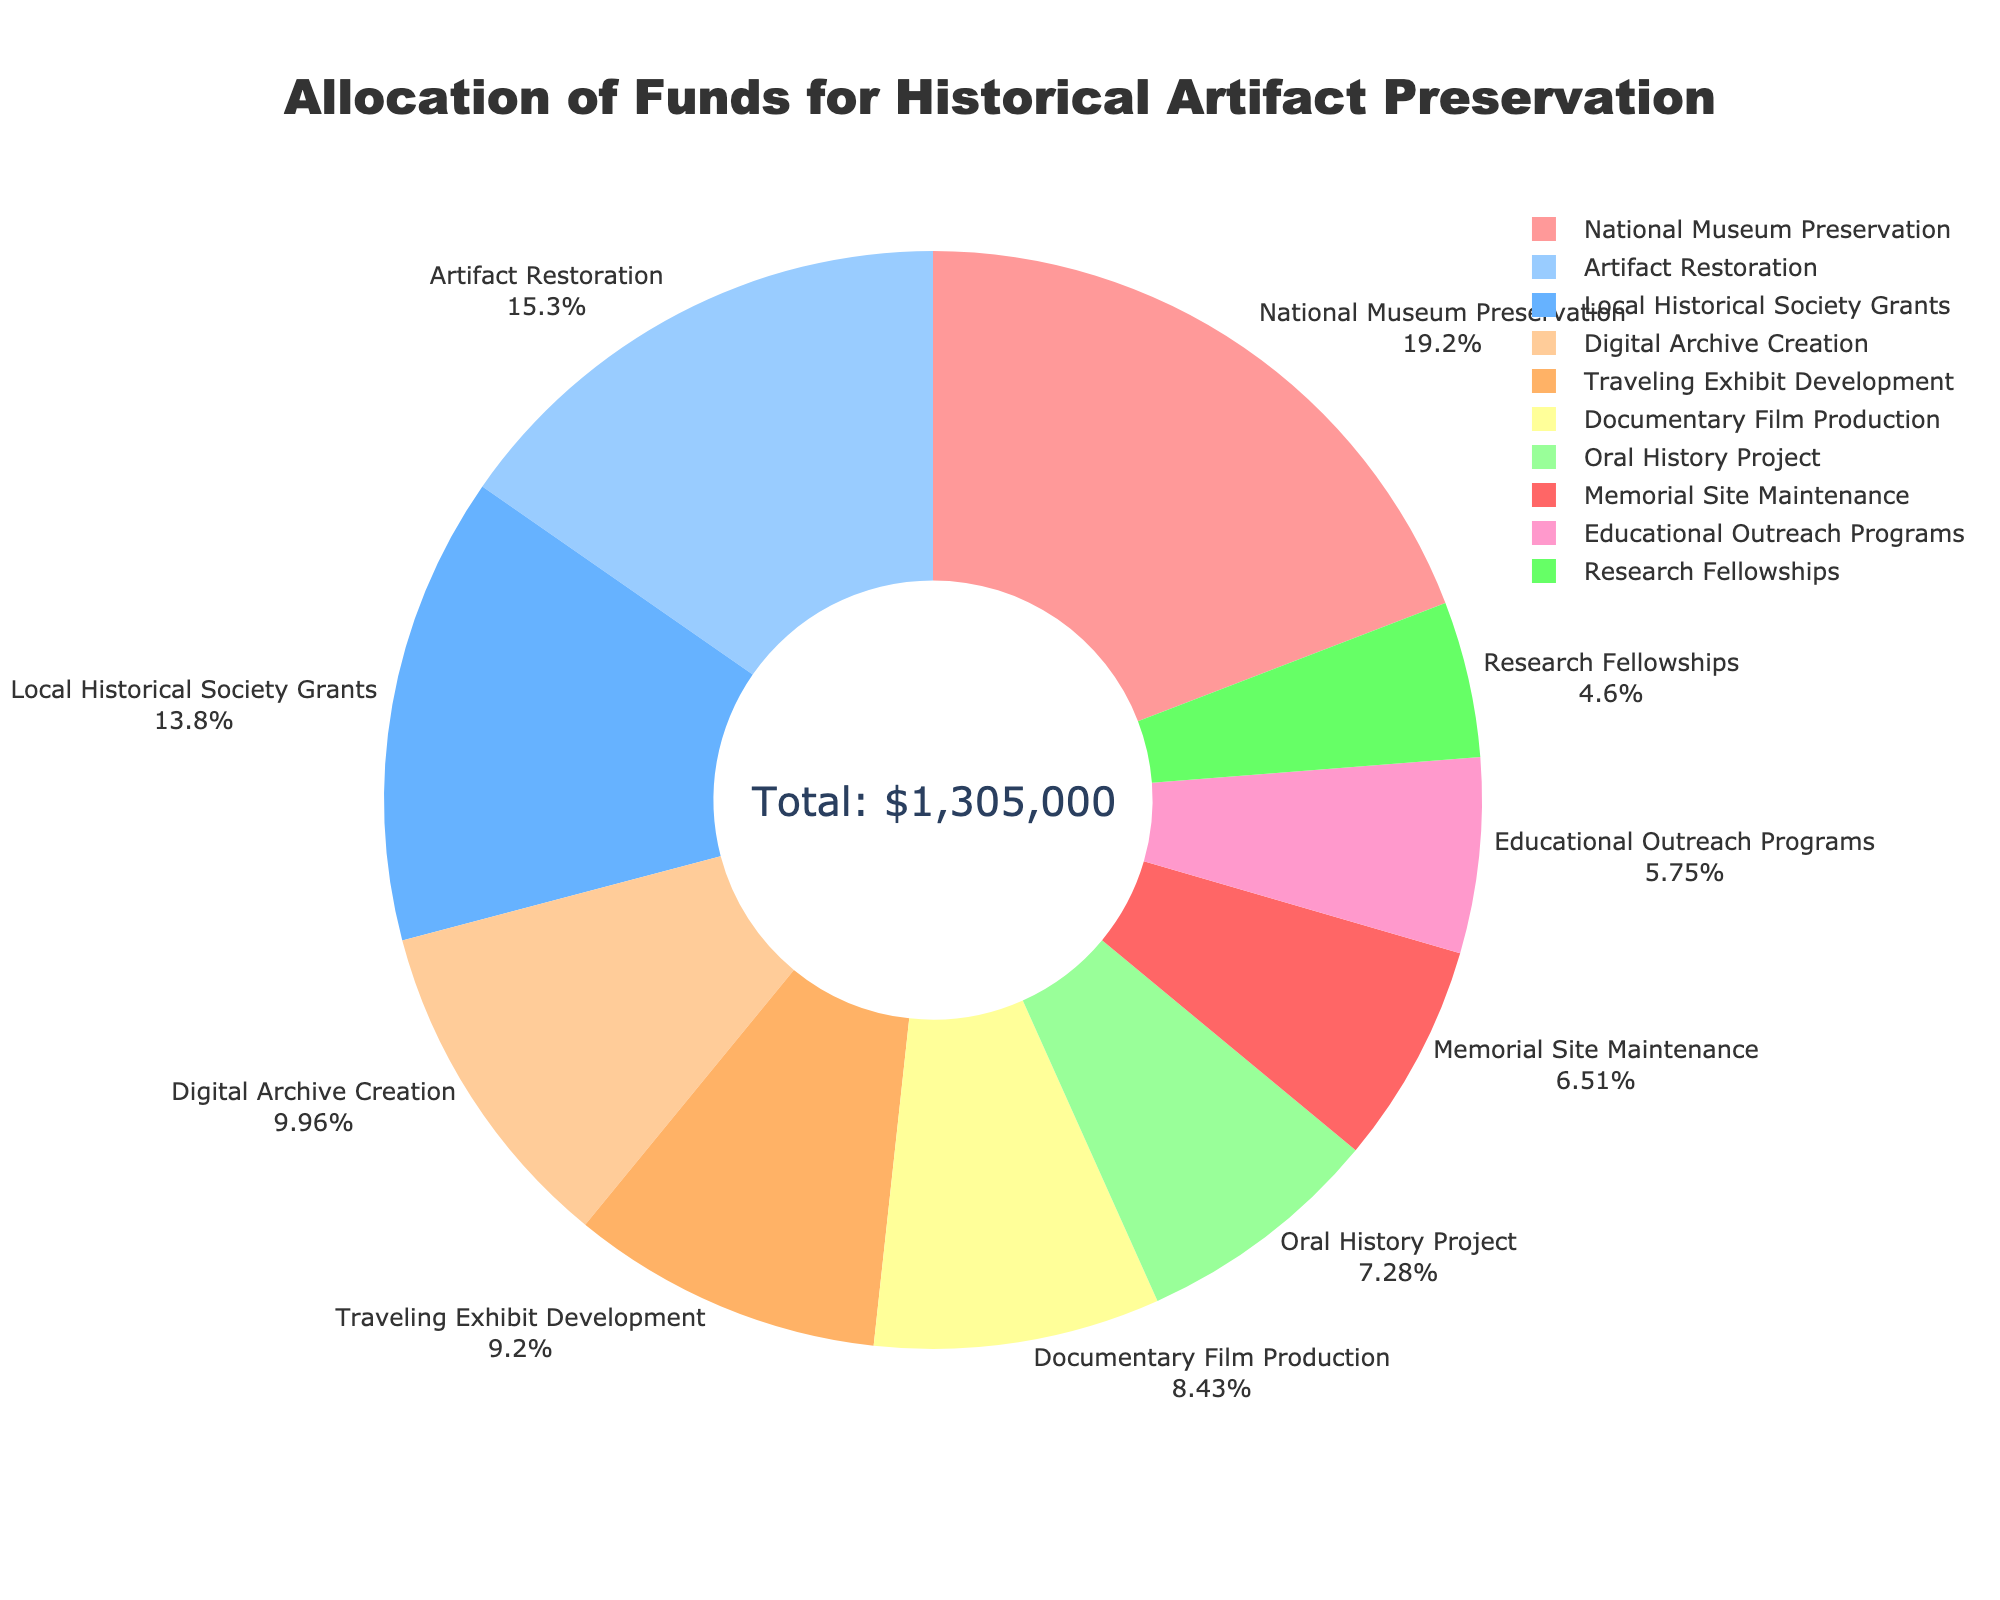Which category receives the highest allocation of funds? The visually largest segment of the donut chart indicates the highest allocation of funds. The text next to the segment marks it as "National Museum Preservation" with the highest amount.
Answer: National Museum Preservation Which category receives the least amount of funds? The smallest segment of the donut chart represents the category with the least amount of funds. The text next to this smallest segment is labeled "Research Fellowships."
Answer: Research Fellowships Is the amount allocated to Oral History Project more or less than the amount allocated to Memorial Site Maintenance? Compare the sizes of the segments labeled "Oral History Project" and "Memorial Site Maintenance." The segment representing "Oral History Project" appears larger than that for "Memorial Site Maintenance."
Answer: More How much is the combined allocation for Digital Archive Creation and Artifact Restoration? Identify the segments labeled "Digital Archive Creation" and "Artifact Restoration." Sum the amounts associated with these labels: 130,000 + 200,000.
Answer: 330,000 Which has a greater allocation, Traveling Exhibit Development or Documentary Film Production? Compare the sizes of the segments labeled "Traveling Exhibit Development" and "Documentary Film Production." The segment for "Documentary Film Production" appears smaller.
Answer: Traveling Exhibit Development What percentage of the funds is allocated to Local Historical Society Grants? Look at the segment labeled "Local Historical Society Grants" and identify the percentage displayed in the text on that segment.
Answer: 13.8% What is the total allocation for Educational Outreach Programs, Memorial Site Maintenance, and Research Fellowships? Identify the values for the segments labeled "Educational Outreach Programs," "Memorial Site Maintenance," and "Research Fellowships." Sum these values: 75,000 + 85,000 + 60,000.
Answer: 220,000 Is the allocation for National Museum Preservation more than twice the allocation for Traveling Exhibit Development? First, identify the amounts allocated to "National Museum Preservation" and "Traveling Exhibit Development." Check if 250,000 is more than twice 120,000: 250,000 > 240,000.
Answer: Yes What color represents the Artifact Restoration category? Identify the segment labeled "Artifact Restoration" and note its color based on the displayed color indicator of the graphical representation.
Answer: Pink Compare the total funds allocated for Local Historical Society Grants, Oral History Project, and Educational Outreach Programs with the funds allocated for National Museum Preservation. Which is higher? First, sum the amounts for "Local Historical Society Grants" (180,000), "Oral History Project" (95,000), and "Educational Outreach Programs" (75,000): 180,000 + 95,000 + 75,000 = 350,000. Next, compare this sum to the amount for "National Museum Preservation" (250,000).
Answer: The sum of the three categories 